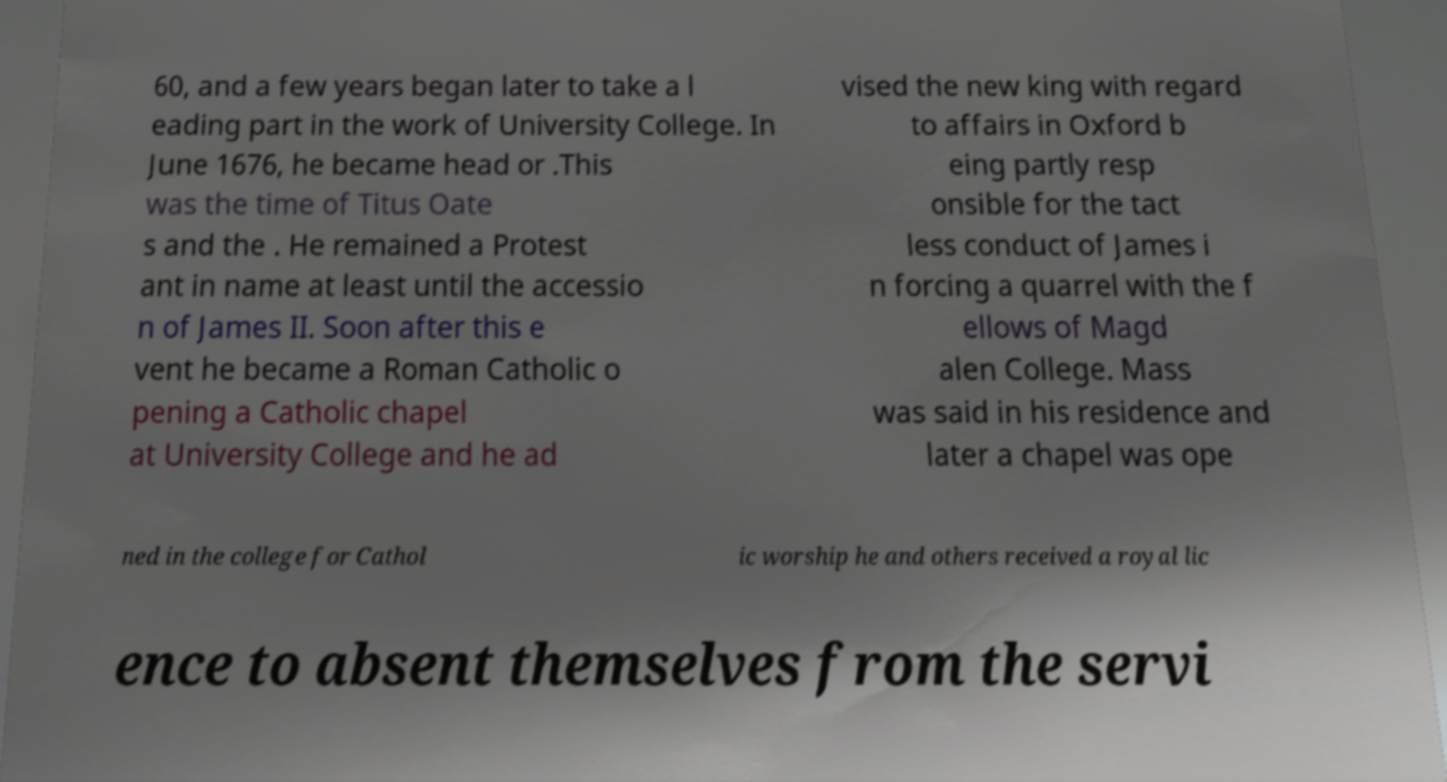Please read and relay the text visible in this image. What does it say? 60, and a few years began later to take a l eading part in the work of University College. In June 1676, he became head or .This was the time of Titus Oate s and the . He remained a Protest ant in name at least until the accessio n of James II. Soon after this e vent he became a Roman Catholic o pening a Catholic chapel at University College and he ad vised the new king with regard to affairs in Oxford b eing partly resp onsible for the tact less conduct of James i n forcing a quarrel with the f ellows of Magd alen College. Mass was said in his residence and later a chapel was ope ned in the college for Cathol ic worship he and others received a royal lic ence to absent themselves from the servi 